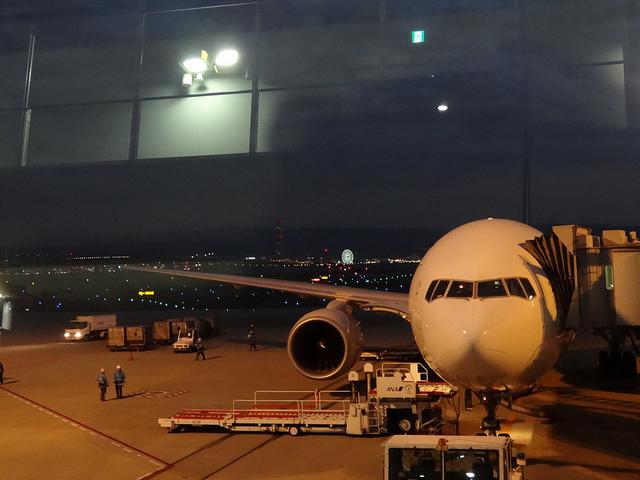How many people can be seen?
Keep it brief. 4. Is there an airplane?
Answer briefly. Yes. Was the pic taken at night?
Quick response, please. Yes. Was the photographer of this photo outside?
Keep it brief. No. 